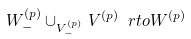<formula> <loc_0><loc_0><loc_500><loc_500>W ^ { ( p ) } _ { - } \cup _ { V ^ { ( p ) } _ { - } } V ^ { ( p ) } \ r t o W ^ { ( p ) }</formula> 